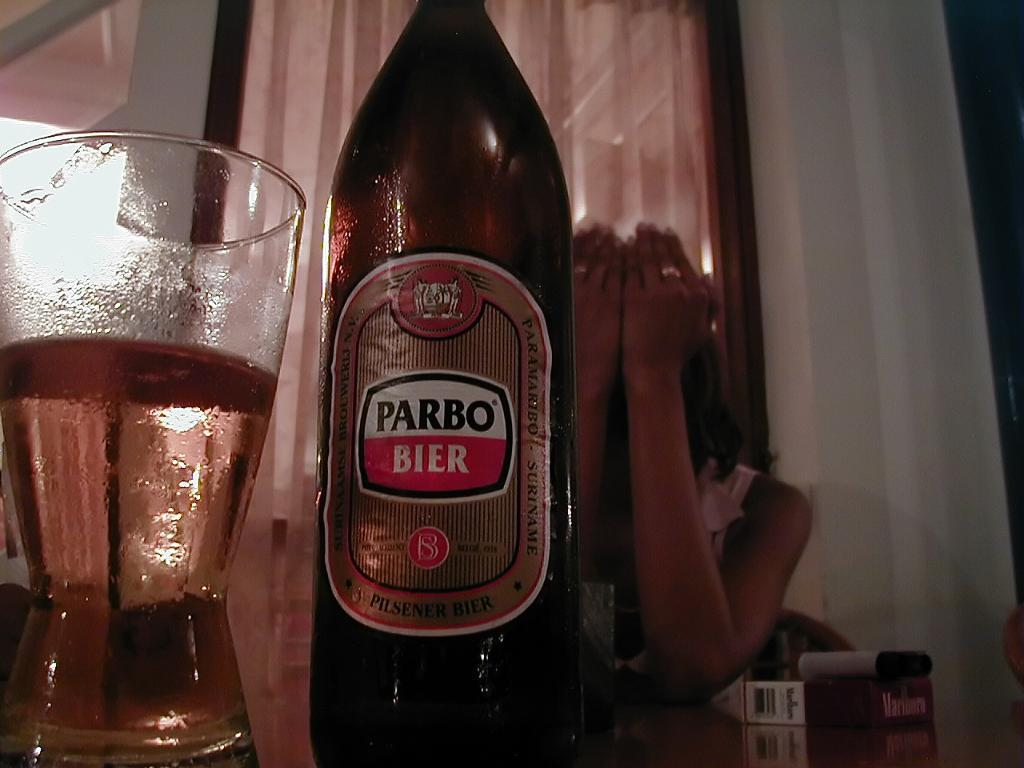<image>
Offer a succinct explanation of the picture presented. A woman sits at a table with her hands covering her face and a bottle and partially filled glass of Parbo Bier in front of her. 